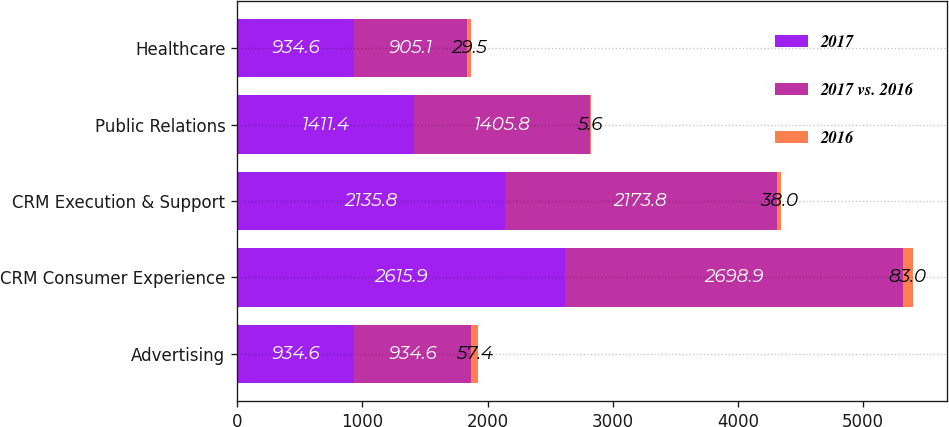Convert chart. <chart><loc_0><loc_0><loc_500><loc_500><stacked_bar_chart><ecel><fcel>Advertising<fcel>CRM Consumer Experience<fcel>CRM Execution & Support<fcel>Public Relations<fcel>Healthcare<nl><fcel>2017<fcel>934.6<fcel>2615.9<fcel>2135.8<fcel>1411.4<fcel>934.6<nl><fcel>2017 vs. 2016<fcel>934.6<fcel>2698.9<fcel>2173.8<fcel>1405.8<fcel>905.1<nl><fcel>2016<fcel>57.4<fcel>83<fcel>38<fcel>5.6<fcel>29.5<nl></chart> 